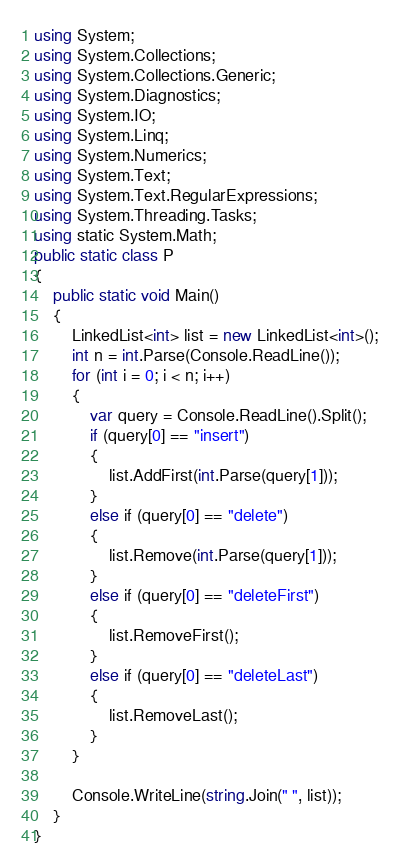Convert code to text. <code><loc_0><loc_0><loc_500><loc_500><_C#_>using System;
using System.Collections;
using System.Collections.Generic;
using System.Diagnostics;
using System.IO;
using System.Linq;
using System.Numerics;
using System.Text;
using System.Text.RegularExpressions;
using System.Threading.Tasks;
using static System.Math;
public static class P
{
    public static void Main()
    {
        LinkedList<int> list = new LinkedList<int>();
        int n = int.Parse(Console.ReadLine());
        for (int i = 0; i < n; i++)
        {
            var query = Console.ReadLine().Split();
            if (query[0] == "insert")
            {
                list.AddFirst(int.Parse(query[1]));
            }
            else if (query[0] == "delete")
            {
                list.Remove(int.Parse(query[1]));
            }
            else if (query[0] == "deleteFirst")
            {
                list.RemoveFirst();
            }
            else if (query[0] == "deleteLast")
            {
                list.RemoveLast();
            }
        }

        Console.WriteLine(string.Join(" ", list));
    }
}
</code> 